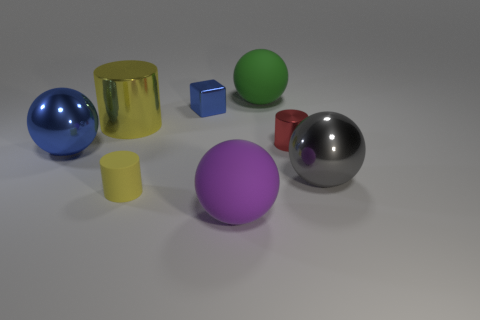Are there fewer cylinders on the left side of the metallic cube than blue spheres?
Provide a succinct answer. No. What is the color of the big thing that is both behind the tiny metallic cylinder and to the left of the tiny yellow matte cylinder?
Give a very brief answer. Yellow. How many other things are the same shape as the purple matte object?
Make the answer very short. 3. Are there fewer purple objects that are to the left of the small metallic cube than large cylinders that are on the right side of the large green thing?
Make the answer very short. No. Is the red cylinder made of the same material as the ball that is behind the blue cube?
Make the answer very short. No. Are there any other things that have the same material as the small blue cube?
Make the answer very short. Yes. Are there more small blue metallic things than blue objects?
Keep it short and to the point. No. There is a large object to the right of the green matte object left of the metallic cylinder in front of the big yellow thing; what is its shape?
Ensure brevity in your answer.  Sphere. Is the tiny cylinder right of the green sphere made of the same material as the big thing that is behind the blue cube?
Your response must be concise. No. What is the shape of the small blue thing that is the same material as the red thing?
Your response must be concise. Cube. 